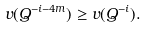<formula> <loc_0><loc_0><loc_500><loc_500>v ( Q ^ { - i - 4 m } ) \geq v ( Q ^ { - i } ) .</formula> 